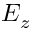<formula> <loc_0><loc_0><loc_500><loc_500>E _ { z }</formula> 